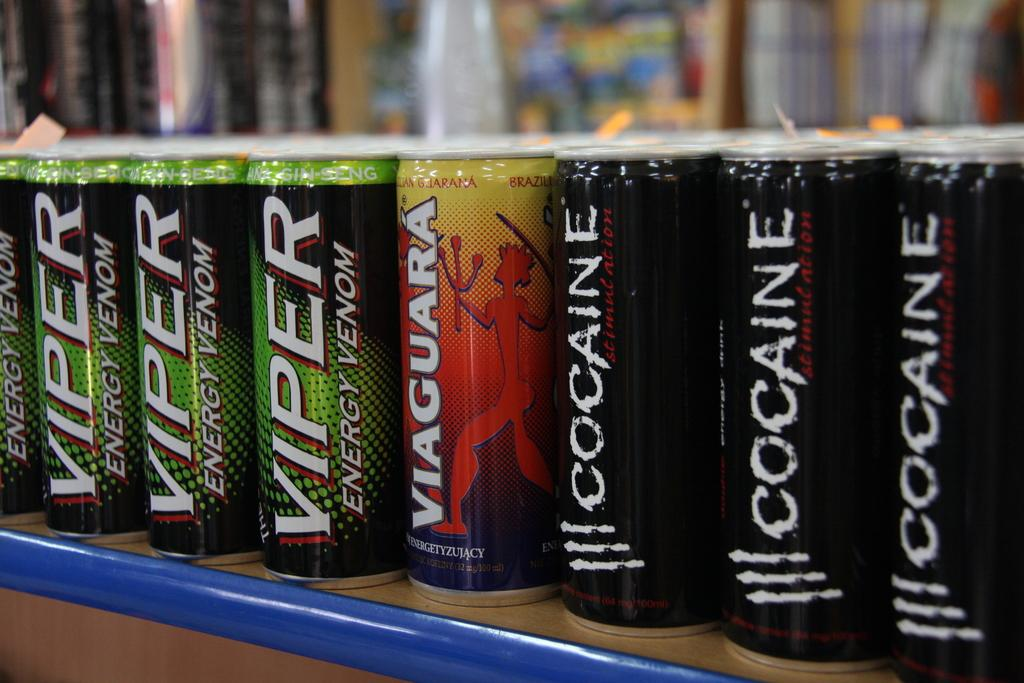What objects are present in the image? There are bottles in the image. Where are the bottles located? The bottles are kept on an object in the middle of the image. What type of shirt is being worn by the cough in the image? There is no shirt or cough present in the image; it only features bottles on an object. 